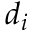Convert formula to latex. <formula><loc_0><loc_0><loc_500><loc_500>d _ { i }</formula> 